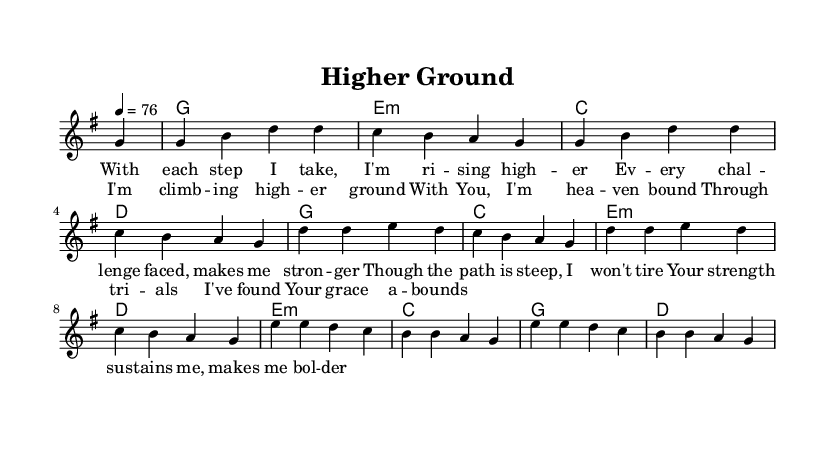what is the key signature of this music? The key signature is G major, which has one sharp (F#). This can be determined from the first part of the score where the key is indicated.
Answer: G major what is the time signature of this music? The time signature is 4/4, which is clearly indicated at the beginning of the score. This means there are four beats in each measure.
Answer: 4/4 what is the tempo of this music? The tempo marking is 76 beats per minute, stated at the beginning of the score as "4 = 76". This indicates the speed at which the piece should be played.
Answer: 76 which chord is played at the start of the piece? The chord played at the start is G major. This is the first chord indicated in the harmonies section, after the rest.
Answer: G how many verses are there in the lyrics section? There is one verse in the lyrics section, which contains four lines that apply to the melody. This can be seen in the structured layout of the lyrics.
Answer: One which line features the theme of strength? The line "Your strength sustains me, makes me bolder" contains the theme of strength, reflecting the perseverance and support mentioned throughout the lyrics. It can be identified in the verse section.
Answer: Your strength sustains me, makes me bolder what musical element signifies a transition to the chorus? The transition to the chorus is signified by the last line of the verse, followed by the chorus section, which is separately indicated in the score. This structural shift denotes a change in thematic focus.
Answer: Chorus 